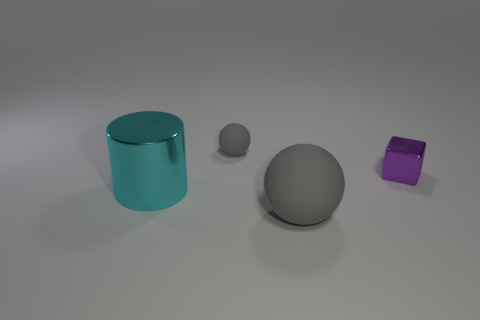Add 3 big blue cylinders. How many objects exist? 7 Subtract all cylinders. How many objects are left? 3 Add 4 small blocks. How many small blocks are left? 5 Add 1 shiny things. How many shiny things exist? 3 Subtract 0 gray cubes. How many objects are left? 4 Subtract all rubber spheres. Subtract all big brown cylinders. How many objects are left? 2 